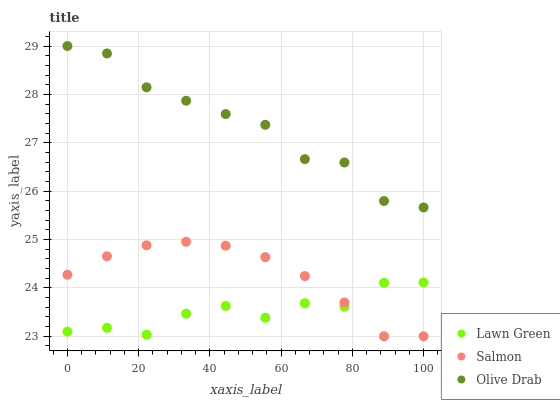Does Lawn Green have the minimum area under the curve?
Answer yes or no. Yes. Does Olive Drab have the maximum area under the curve?
Answer yes or no. Yes. Does Salmon have the minimum area under the curve?
Answer yes or no. No. Does Salmon have the maximum area under the curve?
Answer yes or no. No. Is Salmon the smoothest?
Answer yes or no. Yes. Is Olive Drab the roughest?
Answer yes or no. Yes. Is Olive Drab the smoothest?
Answer yes or no. No. Is Salmon the roughest?
Answer yes or no. No. Does Salmon have the lowest value?
Answer yes or no. Yes. Does Olive Drab have the lowest value?
Answer yes or no. No. Does Olive Drab have the highest value?
Answer yes or no. Yes. Does Salmon have the highest value?
Answer yes or no. No. Is Salmon less than Olive Drab?
Answer yes or no. Yes. Is Olive Drab greater than Salmon?
Answer yes or no. Yes. Does Salmon intersect Lawn Green?
Answer yes or no. Yes. Is Salmon less than Lawn Green?
Answer yes or no. No. Is Salmon greater than Lawn Green?
Answer yes or no. No. Does Salmon intersect Olive Drab?
Answer yes or no. No. 